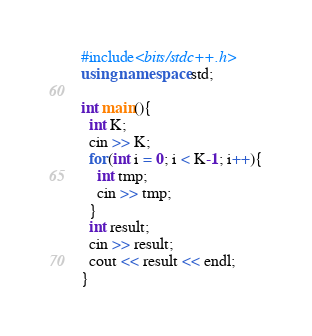Convert code to text. <code><loc_0><loc_0><loc_500><loc_500><_C++_>#include<bits/stdc++.h>
using namespace std;

int main(){
  int K;
  cin >> K;
  for(int i = 0; i < K-1; i++){
    int tmp;
    cin >> tmp;
  }
  int result;
  cin >> result;
  cout << result << endl;
}</code> 